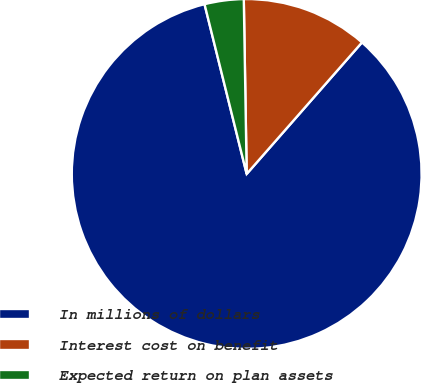<chart> <loc_0><loc_0><loc_500><loc_500><pie_chart><fcel>In millions of dollars<fcel>Interest cost on benefit<fcel>Expected return on plan assets<nl><fcel>84.67%<fcel>11.72%<fcel>3.61%<nl></chart> 